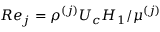<formula> <loc_0><loc_0><loc_500><loc_500>R e _ { j } = \rho ^ { ( j ) } U _ { c } H _ { 1 } / \mu ^ { ( j ) }</formula> 